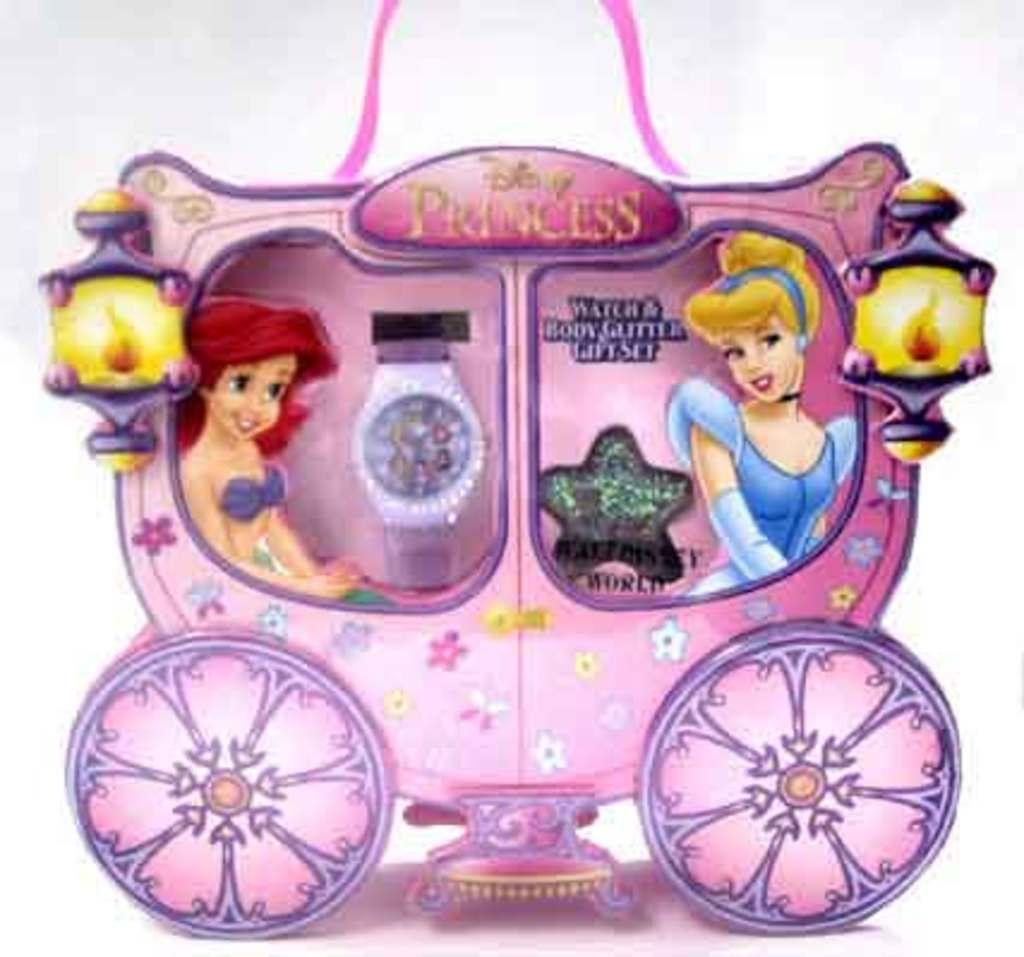Provide a one-sentence caption for the provided image. Hey child's gift set is colored pink and includes body glitter. 